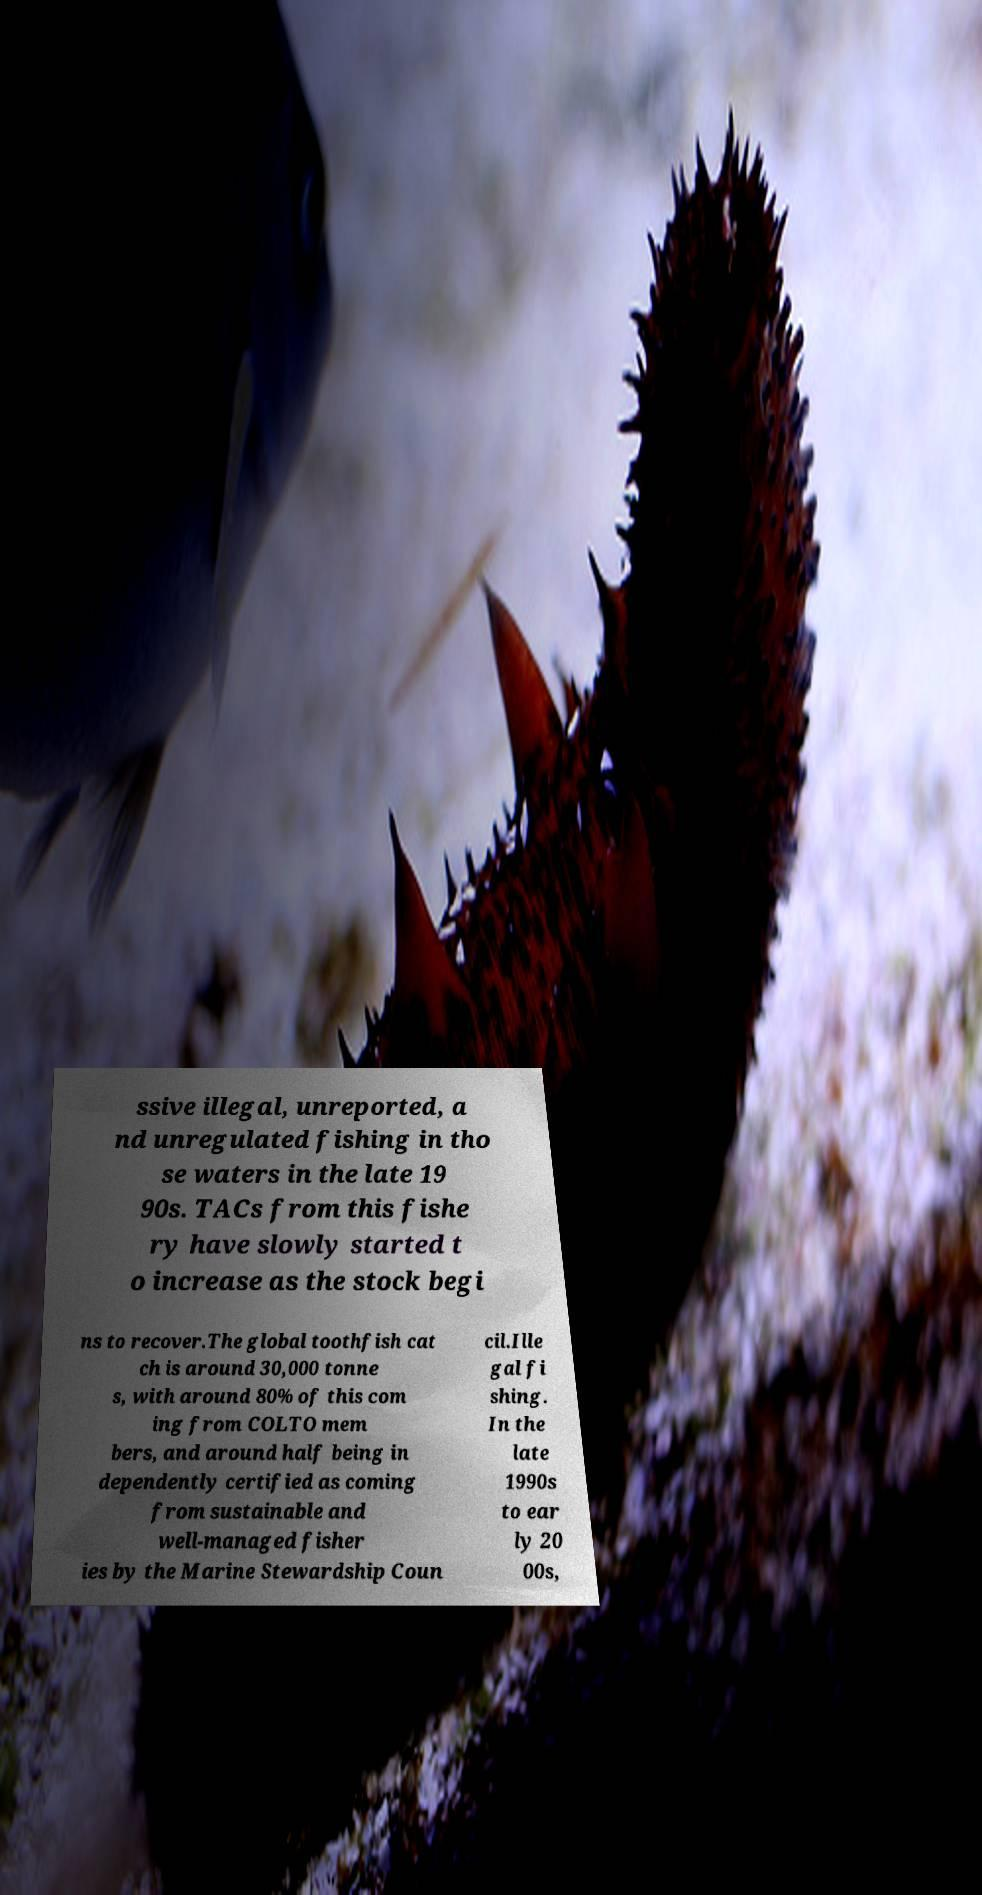I need the written content from this picture converted into text. Can you do that? ssive illegal, unreported, a nd unregulated fishing in tho se waters in the late 19 90s. TACs from this fishe ry have slowly started t o increase as the stock begi ns to recover.The global toothfish cat ch is around 30,000 tonne s, with around 80% of this com ing from COLTO mem bers, and around half being in dependently certified as coming from sustainable and well-managed fisher ies by the Marine Stewardship Coun cil.Ille gal fi shing. In the late 1990s to ear ly 20 00s, 